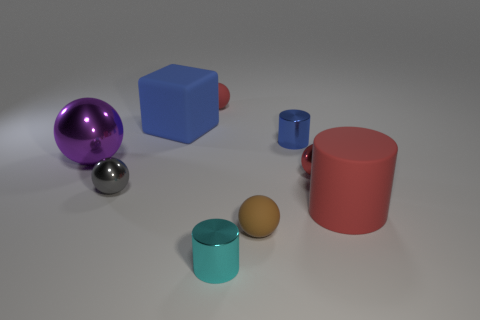Subtract all yellow blocks. How many red spheres are left? 2 Subtract all brown spheres. How many spheres are left? 4 Add 1 blue matte blocks. How many objects exist? 10 Subtract 3 balls. How many balls are left? 2 Subtract all purple balls. How many balls are left? 4 Subtract all green balls. Subtract all gray cubes. How many balls are left? 5 Add 6 small red matte things. How many small red matte things are left? 7 Add 5 big brown objects. How many big brown objects exist? 5 Subtract 0 purple cubes. How many objects are left? 9 Subtract all cylinders. How many objects are left? 6 